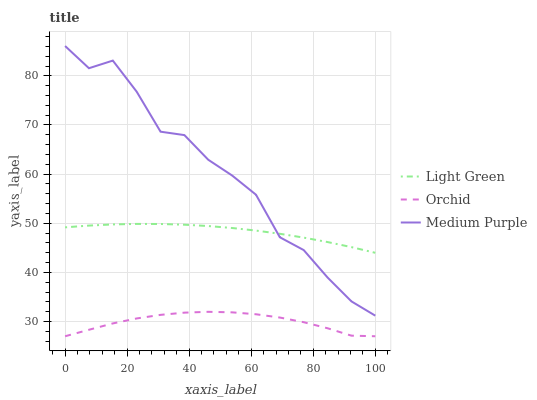Does Orchid have the minimum area under the curve?
Answer yes or no. Yes. Does Medium Purple have the maximum area under the curve?
Answer yes or no. Yes. Does Light Green have the minimum area under the curve?
Answer yes or no. No. Does Light Green have the maximum area under the curve?
Answer yes or no. No. Is Light Green the smoothest?
Answer yes or no. Yes. Is Medium Purple the roughest?
Answer yes or no. Yes. Is Orchid the smoothest?
Answer yes or no. No. Is Orchid the roughest?
Answer yes or no. No. Does Orchid have the lowest value?
Answer yes or no. Yes. Does Light Green have the lowest value?
Answer yes or no. No. Does Medium Purple have the highest value?
Answer yes or no. Yes. Does Light Green have the highest value?
Answer yes or no. No. Is Orchid less than Medium Purple?
Answer yes or no. Yes. Is Light Green greater than Orchid?
Answer yes or no. Yes. Does Light Green intersect Medium Purple?
Answer yes or no. Yes. Is Light Green less than Medium Purple?
Answer yes or no. No. Is Light Green greater than Medium Purple?
Answer yes or no. No. Does Orchid intersect Medium Purple?
Answer yes or no. No. 